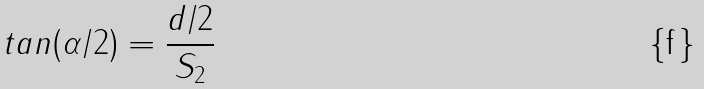<formula> <loc_0><loc_0><loc_500><loc_500>t a n ( \alpha / 2 ) = \frac { d / 2 } { S _ { 2 } }</formula> 